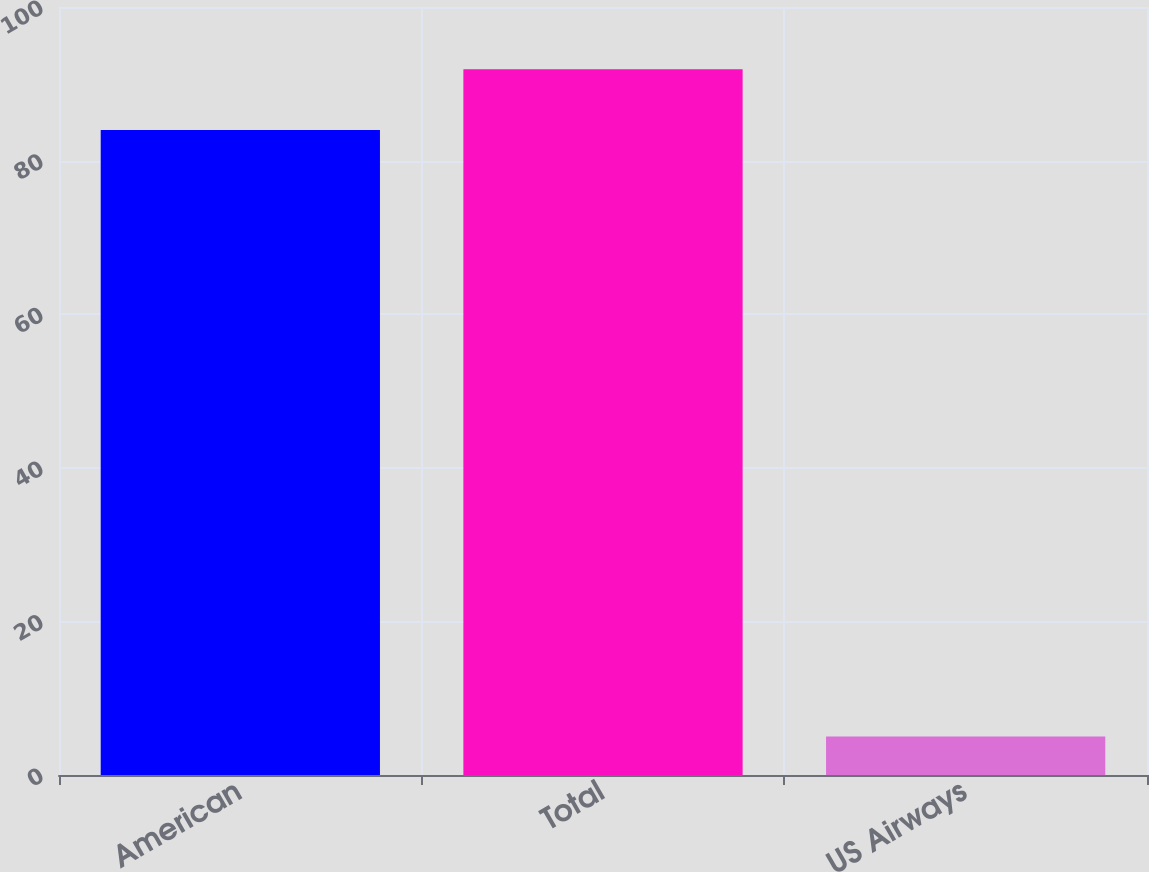<chart> <loc_0><loc_0><loc_500><loc_500><bar_chart><fcel>American<fcel>Total<fcel>US Airways<nl><fcel>84<fcel>91.9<fcel>5<nl></chart> 